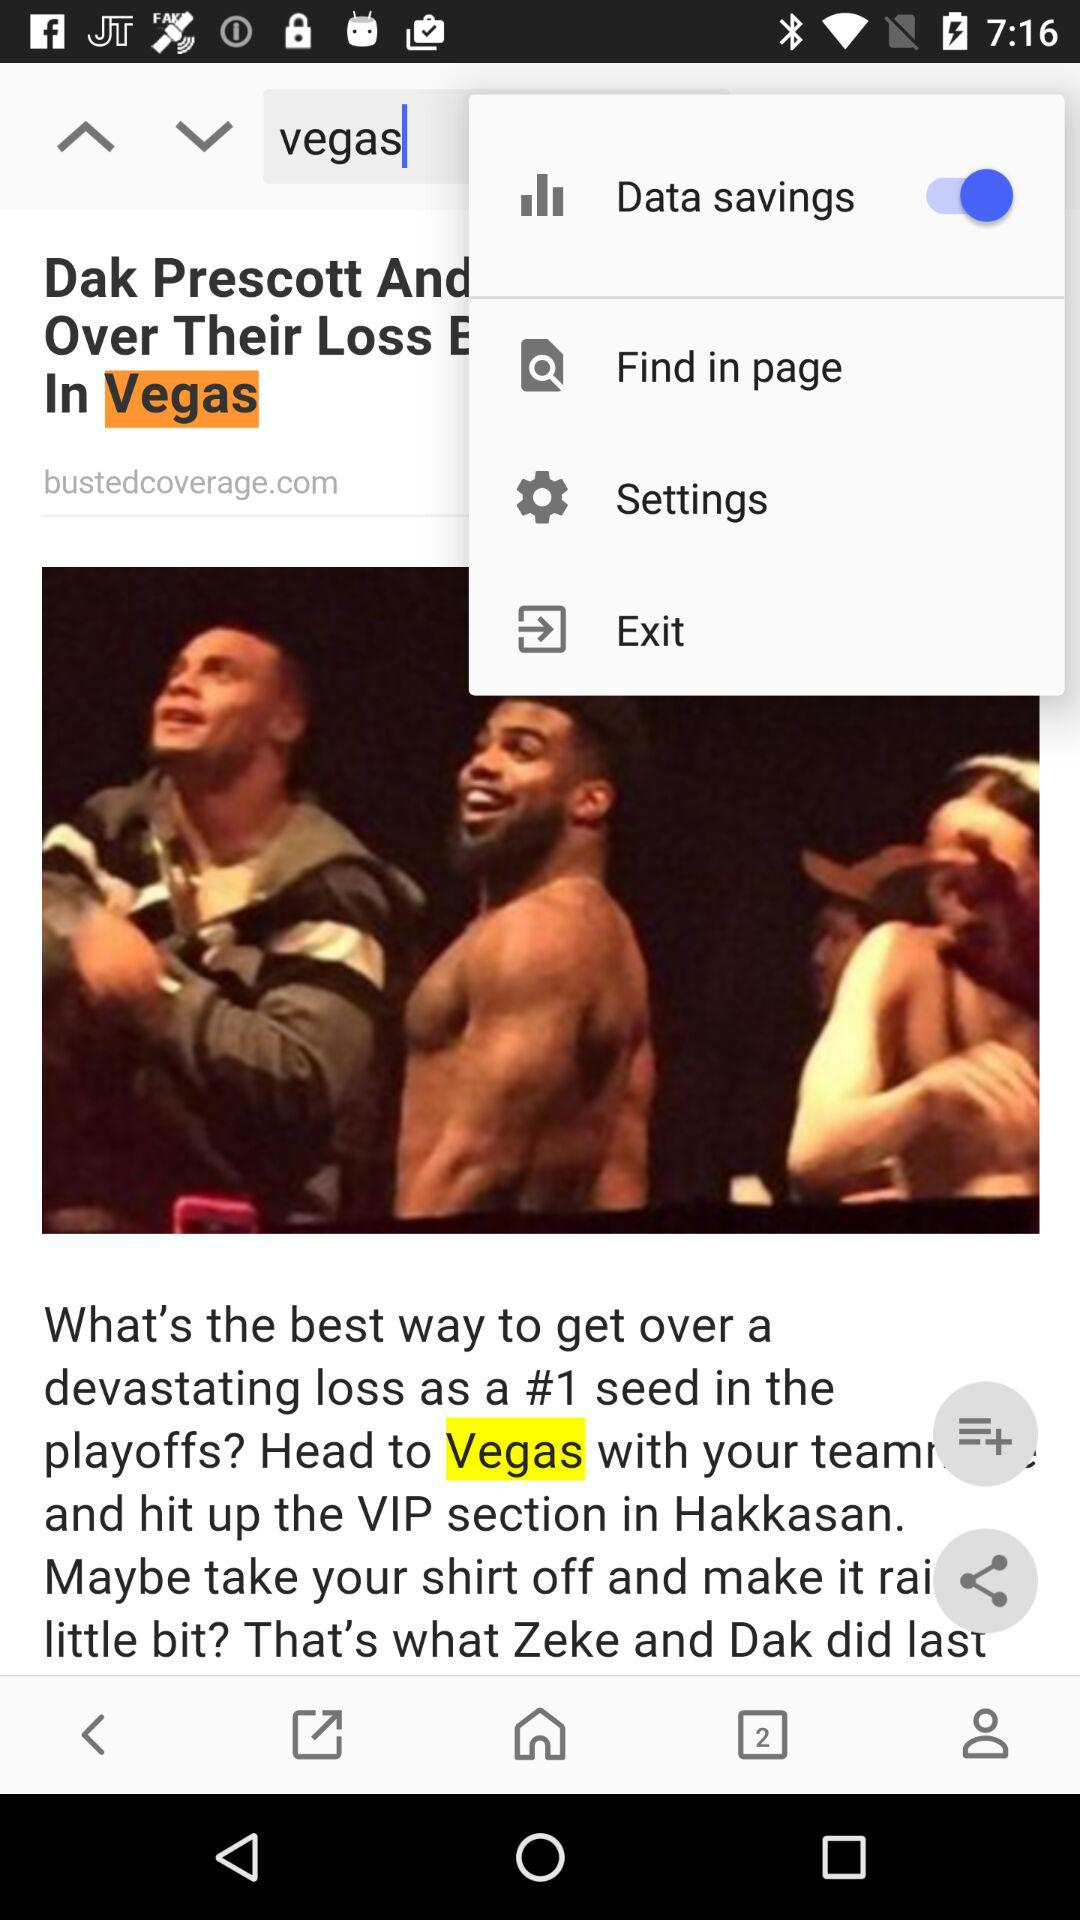What is the status of "Data savings"? The status is "on". 